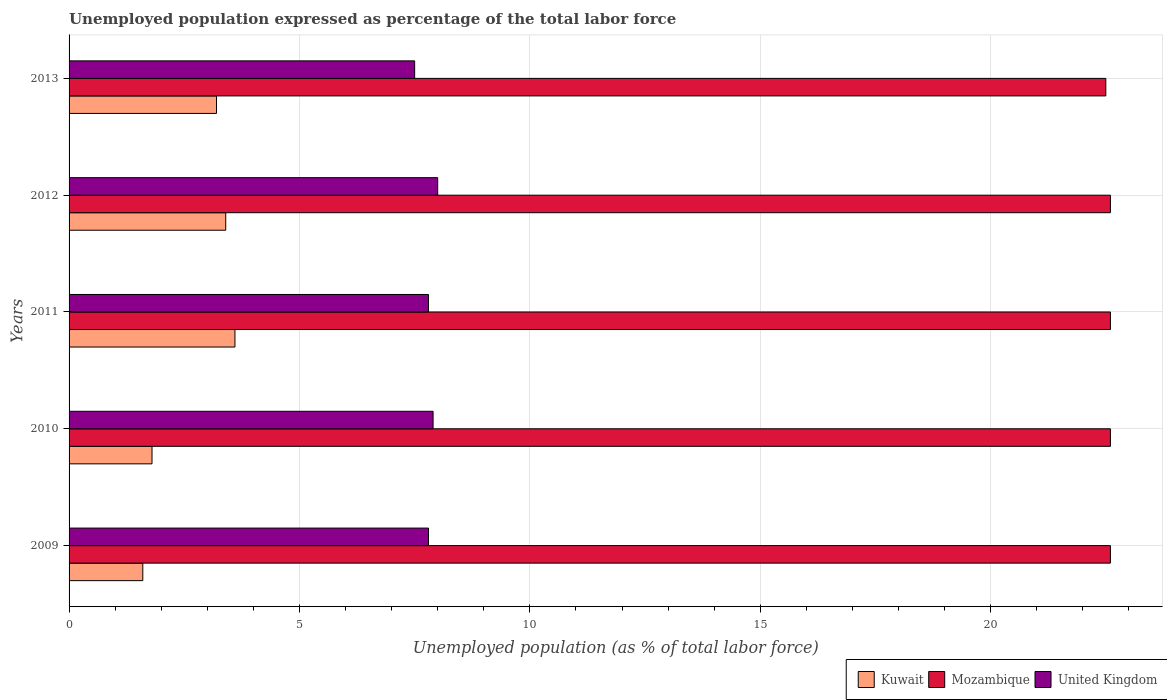How many different coloured bars are there?
Keep it short and to the point. 3. Are the number of bars per tick equal to the number of legend labels?
Offer a terse response. Yes. How many bars are there on the 3rd tick from the top?
Make the answer very short. 3. In how many cases, is the number of bars for a given year not equal to the number of legend labels?
Offer a terse response. 0. Across all years, what is the maximum unemployment in in Kuwait?
Offer a terse response. 3.6. Across all years, what is the minimum unemployment in in United Kingdom?
Your answer should be very brief. 7.5. What is the total unemployment in in Mozambique in the graph?
Your answer should be compact. 112.9. What is the difference between the unemployment in in Mozambique in 2009 and that in 2010?
Offer a very short reply. 0. What is the difference between the unemployment in in United Kingdom in 2010 and the unemployment in in Kuwait in 2011?
Provide a succinct answer. 4.3. What is the average unemployment in in United Kingdom per year?
Keep it short and to the point. 7.8. In the year 2012, what is the difference between the unemployment in in Kuwait and unemployment in in United Kingdom?
Your response must be concise. -4.6. What is the ratio of the unemployment in in United Kingdom in 2011 to that in 2012?
Keep it short and to the point. 0.98. What is the difference between the highest and the lowest unemployment in in Mozambique?
Provide a succinct answer. 0.1. In how many years, is the unemployment in in Mozambique greater than the average unemployment in in Mozambique taken over all years?
Give a very brief answer. 4. Is the sum of the unemployment in in United Kingdom in 2010 and 2013 greater than the maximum unemployment in in Kuwait across all years?
Your answer should be compact. Yes. What does the 1st bar from the bottom in 2011 represents?
Offer a very short reply. Kuwait. How many bars are there?
Make the answer very short. 15. Are all the bars in the graph horizontal?
Your answer should be very brief. Yes. Does the graph contain any zero values?
Offer a terse response. No. Does the graph contain grids?
Offer a very short reply. Yes. Where does the legend appear in the graph?
Keep it short and to the point. Bottom right. How many legend labels are there?
Provide a short and direct response. 3. What is the title of the graph?
Your answer should be compact. Unemployed population expressed as percentage of the total labor force. Does "Croatia" appear as one of the legend labels in the graph?
Provide a succinct answer. No. What is the label or title of the X-axis?
Provide a succinct answer. Unemployed population (as % of total labor force). What is the Unemployed population (as % of total labor force) in Kuwait in 2009?
Your answer should be very brief. 1.6. What is the Unemployed population (as % of total labor force) in Mozambique in 2009?
Your answer should be very brief. 22.6. What is the Unemployed population (as % of total labor force) in United Kingdom in 2009?
Your answer should be compact. 7.8. What is the Unemployed population (as % of total labor force) of Kuwait in 2010?
Give a very brief answer. 1.8. What is the Unemployed population (as % of total labor force) in Mozambique in 2010?
Your answer should be compact. 22.6. What is the Unemployed population (as % of total labor force) of United Kingdom in 2010?
Provide a short and direct response. 7.9. What is the Unemployed population (as % of total labor force) in Kuwait in 2011?
Provide a short and direct response. 3.6. What is the Unemployed population (as % of total labor force) in Mozambique in 2011?
Your answer should be very brief. 22.6. What is the Unemployed population (as % of total labor force) in United Kingdom in 2011?
Your answer should be compact. 7.8. What is the Unemployed population (as % of total labor force) of Kuwait in 2012?
Your answer should be very brief. 3.4. What is the Unemployed population (as % of total labor force) of Mozambique in 2012?
Provide a short and direct response. 22.6. What is the Unemployed population (as % of total labor force) of Kuwait in 2013?
Your response must be concise. 3.2. Across all years, what is the maximum Unemployed population (as % of total labor force) in Kuwait?
Offer a terse response. 3.6. Across all years, what is the maximum Unemployed population (as % of total labor force) in Mozambique?
Ensure brevity in your answer.  22.6. Across all years, what is the maximum Unemployed population (as % of total labor force) in United Kingdom?
Provide a succinct answer. 8. Across all years, what is the minimum Unemployed population (as % of total labor force) in Kuwait?
Give a very brief answer. 1.6. Across all years, what is the minimum Unemployed population (as % of total labor force) in Mozambique?
Offer a very short reply. 22.5. What is the total Unemployed population (as % of total labor force) in Kuwait in the graph?
Make the answer very short. 13.6. What is the total Unemployed population (as % of total labor force) of Mozambique in the graph?
Provide a short and direct response. 112.9. What is the total Unemployed population (as % of total labor force) of United Kingdom in the graph?
Offer a very short reply. 39. What is the difference between the Unemployed population (as % of total labor force) of United Kingdom in 2009 and that in 2010?
Your answer should be very brief. -0.1. What is the difference between the Unemployed population (as % of total labor force) of Mozambique in 2009 and that in 2011?
Your response must be concise. 0. What is the difference between the Unemployed population (as % of total labor force) in United Kingdom in 2009 and that in 2011?
Your answer should be compact. 0. What is the difference between the Unemployed population (as % of total labor force) in United Kingdom in 2009 and that in 2012?
Offer a terse response. -0.2. What is the difference between the Unemployed population (as % of total labor force) in Kuwait in 2010 and that in 2012?
Your response must be concise. -1.6. What is the difference between the Unemployed population (as % of total labor force) of Kuwait in 2010 and that in 2013?
Your answer should be very brief. -1.4. What is the difference between the Unemployed population (as % of total labor force) in Kuwait in 2011 and that in 2012?
Offer a very short reply. 0.2. What is the difference between the Unemployed population (as % of total labor force) of United Kingdom in 2011 and that in 2012?
Your answer should be compact. -0.2. What is the difference between the Unemployed population (as % of total labor force) of Mozambique in 2011 and that in 2013?
Keep it short and to the point. 0.1. What is the difference between the Unemployed population (as % of total labor force) in United Kingdom in 2011 and that in 2013?
Your response must be concise. 0.3. What is the difference between the Unemployed population (as % of total labor force) in Kuwait in 2012 and that in 2013?
Provide a short and direct response. 0.2. What is the difference between the Unemployed population (as % of total labor force) of Mozambique in 2012 and that in 2013?
Offer a very short reply. 0.1. What is the difference between the Unemployed population (as % of total labor force) in Kuwait in 2009 and the Unemployed population (as % of total labor force) in Mozambique in 2010?
Give a very brief answer. -21. What is the difference between the Unemployed population (as % of total labor force) in Kuwait in 2009 and the Unemployed population (as % of total labor force) in Mozambique in 2011?
Keep it short and to the point. -21. What is the difference between the Unemployed population (as % of total labor force) in Kuwait in 2009 and the Unemployed population (as % of total labor force) in United Kingdom in 2011?
Your answer should be very brief. -6.2. What is the difference between the Unemployed population (as % of total labor force) in Mozambique in 2009 and the Unemployed population (as % of total labor force) in United Kingdom in 2012?
Provide a short and direct response. 14.6. What is the difference between the Unemployed population (as % of total labor force) in Kuwait in 2009 and the Unemployed population (as % of total labor force) in Mozambique in 2013?
Your response must be concise. -20.9. What is the difference between the Unemployed population (as % of total labor force) of Kuwait in 2009 and the Unemployed population (as % of total labor force) of United Kingdom in 2013?
Your answer should be compact. -5.9. What is the difference between the Unemployed population (as % of total labor force) in Kuwait in 2010 and the Unemployed population (as % of total labor force) in Mozambique in 2011?
Offer a very short reply. -20.8. What is the difference between the Unemployed population (as % of total labor force) of Kuwait in 2010 and the Unemployed population (as % of total labor force) of Mozambique in 2012?
Give a very brief answer. -20.8. What is the difference between the Unemployed population (as % of total labor force) in Kuwait in 2010 and the Unemployed population (as % of total labor force) in United Kingdom in 2012?
Give a very brief answer. -6.2. What is the difference between the Unemployed population (as % of total labor force) in Kuwait in 2010 and the Unemployed population (as % of total labor force) in Mozambique in 2013?
Offer a terse response. -20.7. What is the difference between the Unemployed population (as % of total labor force) in Kuwait in 2010 and the Unemployed population (as % of total labor force) in United Kingdom in 2013?
Your answer should be very brief. -5.7. What is the difference between the Unemployed population (as % of total labor force) of Mozambique in 2010 and the Unemployed population (as % of total labor force) of United Kingdom in 2013?
Offer a very short reply. 15.1. What is the difference between the Unemployed population (as % of total labor force) in Kuwait in 2011 and the Unemployed population (as % of total labor force) in United Kingdom in 2012?
Your answer should be compact. -4.4. What is the difference between the Unemployed population (as % of total labor force) of Mozambique in 2011 and the Unemployed population (as % of total labor force) of United Kingdom in 2012?
Provide a succinct answer. 14.6. What is the difference between the Unemployed population (as % of total labor force) in Kuwait in 2011 and the Unemployed population (as % of total labor force) in Mozambique in 2013?
Your response must be concise. -18.9. What is the difference between the Unemployed population (as % of total labor force) of Kuwait in 2011 and the Unemployed population (as % of total labor force) of United Kingdom in 2013?
Give a very brief answer. -3.9. What is the difference between the Unemployed population (as % of total labor force) of Kuwait in 2012 and the Unemployed population (as % of total labor force) of Mozambique in 2013?
Give a very brief answer. -19.1. What is the average Unemployed population (as % of total labor force) of Kuwait per year?
Ensure brevity in your answer.  2.72. What is the average Unemployed population (as % of total labor force) in Mozambique per year?
Provide a short and direct response. 22.58. In the year 2009, what is the difference between the Unemployed population (as % of total labor force) in Kuwait and Unemployed population (as % of total labor force) in Mozambique?
Offer a terse response. -21. In the year 2009, what is the difference between the Unemployed population (as % of total labor force) in Mozambique and Unemployed population (as % of total labor force) in United Kingdom?
Offer a terse response. 14.8. In the year 2010, what is the difference between the Unemployed population (as % of total labor force) in Kuwait and Unemployed population (as % of total labor force) in Mozambique?
Give a very brief answer. -20.8. In the year 2010, what is the difference between the Unemployed population (as % of total labor force) of Kuwait and Unemployed population (as % of total labor force) of United Kingdom?
Keep it short and to the point. -6.1. In the year 2011, what is the difference between the Unemployed population (as % of total labor force) of Kuwait and Unemployed population (as % of total labor force) of United Kingdom?
Ensure brevity in your answer.  -4.2. In the year 2011, what is the difference between the Unemployed population (as % of total labor force) of Mozambique and Unemployed population (as % of total labor force) of United Kingdom?
Provide a short and direct response. 14.8. In the year 2012, what is the difference between the Unemployed population (as % of total labor force) of Kuwait and Unemployed population (as % of total labor force) of Mozambique?
Provide a succinct answer. -19.2. In the year 2012, what is the difference between the Unemployed population (as % of total labor force) in Mozambique and Unemployed population (as % of total labor force) in United Kingdom?
Give a very brief answer. 14.6. In the year 2013, what is the difference between the Unemployed population (as % of total labor force) of Kuwait and Unemployed population (as % of total labor force) of Mozambique?
Provide a short and direct response. -19.3. In the year 2013, what is the difference between the Unemployed population (as % of total labor force) of Mozambique and Unemployed population (as % of total labor force) of United Kingdom?
Provide a short and direct response. 15. What is the ratio of the Unemployed population (as % of total labor force) of United Kingdom in 2009 to that in 2010?
Make the answer very short. 0.99. What is the ratio of the Unemployed population (as % of total labor force) of Kuwait in 2009 to that in 2011?
Offer a terse response. 0.44. What is the ratio of the Unemployed population (as % of total labor force) in Kuwait in 2009 to that in 2012?
Provide a short and direct response. 0.47. What is the ratio of the Unemployed population (as % of total labor force) of Mozambique in 2009 to that in 2012?
Offer a very short reply. 1. What is the ratio of the Unemployed population (as % of total labor force) of Kuwait in 2010 to that in 2011?
Your response must be concise. 0.5. What is the ratio of the Unemployed population (as % of total labor force) in Mozambique in 2010 to that in 2011?
Provide a short and direct response. 1. What is the ratio of the Unemployed population (as % of total labor force) in United Kingdom in 2010 to that in 2011?
Provide a succinct answer. 1.01. What is the ratio of the Unemployed population (as % of total labor force) of Kuwait in 2010 to that in 2012?
Provide a succinct answer. 0.53. What is the ratio of the Unemployed population (as % of total labor force) of Mozambique in 2010 to that in 2012?
Provide a short and direct response. 1. What is the ratio of the Unemployed population (as % of total labor force) in United Kingdom in 2010 to that in 2012?
Give a very brief answer. 0.99. What is the ratio of the Unemployed population (as % of total labor force) of Kuwait in 2010 to that in 2013?
Your response must be concise. 0.56. What is the ratio of the Unemployed population (as % of total labor force) in United Kingdom in 2010 to that in 2013?
Give a very brief answer. 1.05. What is the ratio of the Unemployed population (as % of total labor force) in Kuwait in 2011 to that in 2012?
Offer a terse response. 1.06. What is the ratio of the Unemployed population (as % of total labor force) in Mozambique in 2011 to that in 2012?
Your answer should be very brief. 1. What is the ratio of the Unemployed population (as % of total labor force) in Kuwait in 2011 to that in 2013?
Make the answer very short. 1.12. What is the ratio of the Unemployed population (as % of total labor force) in Mozambique in 2011 to that in 2013?
Provide a short and direct response. 1. What is the ratio of the Unemployed population (as % of total labor force) of United Kingdom in 2012 to that in 2013?
Your response must be concise. 1.07. What is the difference between the highest and the second highest Unemployed population (as % of total labor force) of Kuwait?
Your answer should be compact. 0.2. What is the difference between the highest and the second highest Unemployed population (as % of total labor force) in Mozambique?
Ensure brevity in your answer.  0. What is the difference between the highest and the lowest Unemployed population (as % of total labor force) of Kuwait?
Your answer should be very brief. 2. What is the difference between the highest and the lowest Unemployed population (as % of total labor force) in Mozambique?
Give a very brief answer. 0.1. What is the difference between the highest and the lowest Unemployed population (as % of total labor force) in United Kingdom?
Your response must be concise. 0.5. 